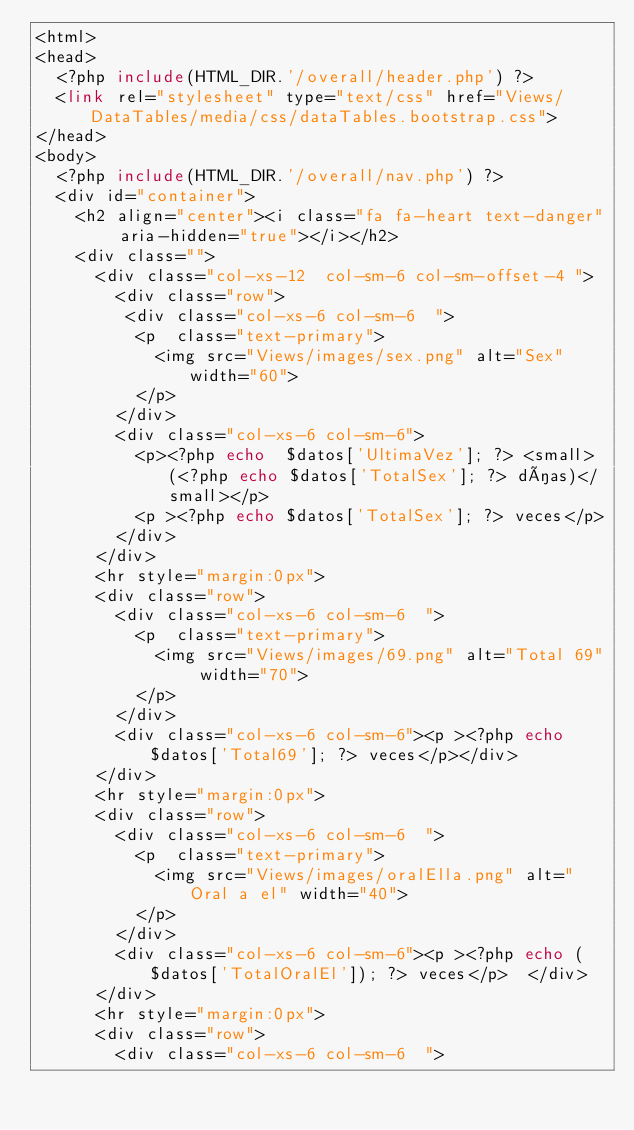Convert code to text. <code><loc_0><loc_0><loc_500><loc_500><_PHP_><html>
<head>
  <?php include(HTML_DIR.'/overall/header.php') ?>
  <link rel="stylesheet" type="text/css" href="Views/DataTables/media/css/dataTables.bootstrap.css">
</head>
<body>
  <?php include(HTML_DIR.'/overall/nav.php') ?>
  <div id="container">
    <h2 align="center"><i class="fa fa-heart text-danger" aria-hidden="true"></i></h2>
    <div class="">
      <div class="col-xs-12  col-sm-6 col-sm-offset-4 ">
        <div class="row">
         <div class="col-xs-6 col-sm-6  ">
          <p  class="text-primary">
            <img src="Views/images/sex.png" alt="Sex" width="60">
          </p>
        </div>
        <div class="col-xs-6 col-sm-6">
          <p><?php echo  $datos['UltimaVez']; ?> <small> (<?php echo $datos['TotalSex']; ?> días)</small></p>
          <p ><?php echo $datos['TotalSex']; ?> veces</p>
        </div>
      </div>
      <hr style="margin:0px">
      <div class="row">
        <div class="col-xs-6 col-sm-6  ">
          <p  class="text-primary">
            <img src="Views/images/69.png" alt="Total 69" width="70">
          </p>
        </div>
        <div class="col-xs-6 col-sm-6"><p ><?php echo $datos['Total69']; ?> veces</p></div>
      </div>
      <hr style="margin:0px">
      <div class="row">
        <div class="col-xs-6 col-sm-6  ">
          <p  class="text-primary">
            <img src="Views/images/oralElla.png" alt="Oral a el" width="40">
          </p>
        </div>
        <div class="col-xs-6 col-sm-6"><p ><?php echo ($datos['TotalOralEl']); ?> veces</p>  </div>
      </div>
      <hr style="margin:0px">
      <div class="row">
        <div class="col-xs-6 col-sm-6  "></code> 